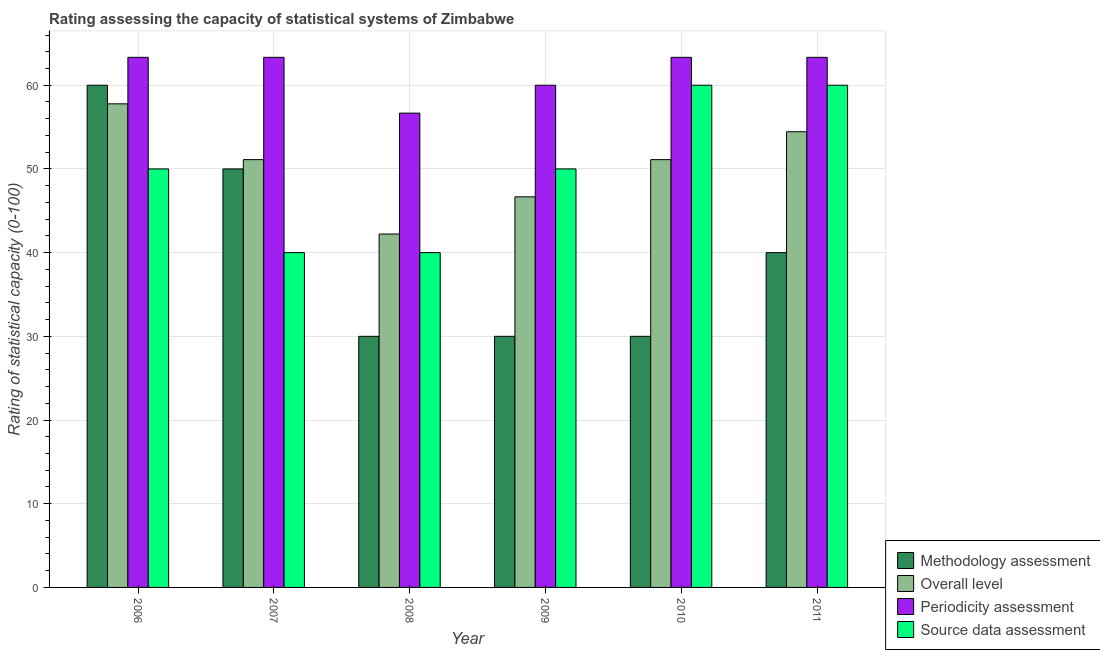How many groups of bars are there?
Make the answer very short. 6. Are the number of bars on each tick of the X-axis equal?
Provide a succinct answer. Yes. How many bars are there on the 3rd tick from the right?
Make the answer very short. 4. What is the periodicity assessment rating in 2006?
Make the answer very short. 63.33. Across all years, what is the maximum overall level rating?
Offer a very short reply. 57.78. Across all years, what is the minimum periodicity assessment rating?
Provide a short and direct response. 56.67. What is the total source data assessment rating in the graph?
Keep it short and to the point. 300. What is the difference between the overall level rating in 2007 and that in 2008?
Provide a short and direct response. 8.89. What is the difference between the source data assessment rating in 2008 and the periodicity assessment rating in 2010?
Give a very brief answer. -20. What is the average periodicity assessment rating per year?
Keep it short and to the point. 61.67. In the year 2008, what is the difference between the methodology assessment rating and source data assessment rating?
Your answer should be compact. 0. What is the ratio of the periodicity assessment rating in 2008 to that in 2011?
Offer a terse response. 0.89. Is the methodology assessment rating in 2006 less than that in 2010?
Provide a succinct answer. No. What is the difference between the highest and the lowest source data assessment rating?
Your answer should be very brief. 20. In how many years, is the overall level rating greater than the average overall level rating taken over all years?
Offer a terse response. 4. What does the 2nd bar from the left in 2010 represents?
Provide a short and direct response. Overall level. What does the 2nd bar from the right in 2010 represents?
Provide a short and direct response. Periodicity assessment. Is it the case that in every year, the sum of the methodology assessment rating and overall level rating is greater than the periodicity assessment rating?
Your answer should be compact. Yes. How many bars are there?
Offer a very short reply. 24. What is the difference between two consecutive major ticks on the Y-axis?
Provide a short and direct response. 10. Where does the legend appear in the graph?
Your answer should be very brief. Bottom right. How are the legend labels stacked?
Provide a succinct answer. Vertical. What is the title of the graph?
Offer a very short reply. Rating assessing the capacity of statistical systems of Zimbabwe. Does "Offering training" appear as one of the legend labels in the graph?
Ensure brevity in your answer.  No. What is the label or title of the X-axis?
Give a very brief answer. Year. What is the label or title of the Y-axis?
Make the answer very short. Rating of statistical capacity (0-100). What is the Rating of statistical capacity (0-100) in Overall level in 2006?
Ensure brevity in your answer.  57.78. What is the Rating of statistical capacity (0-100) of Periodicity assessment in 2006?
Give a very brief answer. 63.33. What is the Rating of statistical capacity (0-100) in Source data assessment in 2006?
Make the answer very short. 50. What is the Rating of statistical capacity (0-100) of Methodology assessment in 2007?
Provide a short and direct response. 50. What is the Rating of statistical capacity (0-100) of Overall level in 2007?
Provide a short and direct response. 51.11. What is the Rating of statistical capacity (0-100) in Periodicity assessment in 2007?
Offer a terse response. 63.33. What is the Rating of statistical capacity (0-100) in Overall level in 2008?
Ensure brevity in your answer.  42.22. What is the Rating of statistical capacity (0-100) in Periodicity assessment in 2008?
Ensure brevity in your answer.  56.67. What is the Rating of statistical capacity (0-100) in Methodology assessment in 2009?
Provide a succinct answer. 30. What is the Rating of statistical capacity (0-100) of Overall level in 2009?
Keep it short and to the point. 46.67. What is the Rating of statistical capacity (0-100) of Periodicity assessment in 2009?
Provide a short and direct response. 60. What is the Rating of statistical capacity (0-100) of Source data assessment in 2009?
Offer a terse response. 50. What is the Rating of statistical capacity (0-100) of Methodology assessment in 2010?
Provide a succinct answer. 30. What is the Rating of statistical capacity (0-100) of Overall level in 2010?
Offer a very short reply. 51.11. What is the Rating of statistical capacity (0-100) of Periodicity assessment in 2010?
Keep it short and to the point. 63.33. What is the Rating of statistical capacity (0-100) of Methodology assessment in 2011?
Your answer should be compact. 40. What is the Rating of statistical capacity (0-100) in Overall level in 2011?
Provide a short and direct response. 54.44. What is the Rating of statistical capacity (0-100) of Periodicity assessment in 2011?
Keep it short and to the point. 63.33. What is the Rating of statistical capacity (0-100) in Source data assessment in 2011?
Offer a very short reply. 60. Across all years, what is the maximum Rating of statistical capacity (0-100) in Methodology assessment?
Your answer should be compact. 60. Across all years, what is the maximum Rating of statistical capacity (0-100) of Overall level?
Give a very brief answer. 57.78. Across all years, what is the maximum Rating of statistical capacity (0-100) of Periodicity assessment?
Your answer should be very brief. 63.33. Across all years, what is the maximum Rating of statistical capacity (0-100) in Source data assessment?
Keep it short and to the point. 60. Across all years, what is the minimum Rating of statistical capacity (0-100) in Overall level?
Ensure brevity in your answer.  42.22. Across all years, what is the minimum Rating of statistical capacity (0-100) of Periodicity assessment?
Offer a terse response. 56.67. Across all years, what is the minimum Rating of statistical capacity (0-100) of Source data assessment?
Provide a succinct answer. 40. What is the total Rating of statistical capacity (0-100) in Methodology assessment in the graph?
Ensure brevity in your answer.  240. What is the total Rating of statistical capacity (0-100) of Overall level in the graph?
Provide a succinct answer. 303.33. What is the total Rating of statistical capacity (0-100) in Periodicity assessment in the graph?
Your answer should be very brief. 370. What is the total Rating of statistical capacity (0-100) of Source data assessment in the graph?
Offer a very short reply. 300. What is the difference between the Rating of statistical capacity (0-100) in Overall level in 2006 and that in 2007?
Provide a short and direct response. 6.67. What is the difference between the Rating of statistical capacity (0-100) of Periodicity assessment in 2006 and that in 2007?
Ensure brevity in your answer.  0. What is the difference between the Rating of statistical capacity (0-100) of Source data assessment in 2006 and that in 2007?
Offer a very short reply. 10. What is the difference between the Rating of statistical capacity (0-100) in Methodology assessment in 2006 and that in 2008?
Keep it short and to the point. 30. What is the difference between the Rating of statistical capacity (0-100) of Overall level in 2006 and that in 2008?
Give a very brief answer. 15.56. What is the difference between the Rating of statistical capacity (0-100) in Periodicity assessment in 2006 and that in 2008?
Provide a short and direct response. 6.67. What is the difference between the Rating of statistical capacity (0-100) of Source data assessment in 2006 and that in 2008?
Provide a short and direct response. 10. What is the difference between the Rating of statistical capacity (0-100) of Overall level in 2006 and that in 2009?
Ensure brevity in your answer.  11.11. What is the difference between the Rating of statistical capacity (0-100) in Source data assessment in 2006 and that in 2009?
Your response must be concise. 0. What is the difference between the Rating of statistical capacity (0-100) of Methodology assessment in 2006 and that in 2010?
Your response must be concise. 30. What is the difference between the Rating of statistical capacity (0-100) of Overall level in 2006 and that in 2010?
Your answer should be compact. 6.67. What is the difference between the Rating of statistical capacity (0-100) of Periodicity assessment in 2006 and that in 2010?
Provide a short and direct response. 0. What is the difference between the Rating of statistical capacity (0-100) of Source data assessment in 2006 and that in 2010?
Your response must be concise. -10. What is the difference between the Rating of statistical capacity (0-100) of Methodology assessment in 2006 and that in 2011?
Your response must be concise. 20. What is the difference between the Rating of statistical capacity (0-100) in Overall level in 2006 and that in 2011?
Your answer should be very brief. 3.33. What is the difference between the Rating of statistical capacity (0-100) of Periodicity assessment in 2006 and that in 2011?
Your response must be concise. 0. What is the difference between the Rating of statistical capacity (0-100) in Source data assessment in 2006 and that in 2011?
Offer a very short reply. -10. What is the difference between the Rating of statistical capacity (0-100) of Methodology assessment in 2007 and that in 2008?
Provide a short and direct response. 20. What is the difference between the Rating of statistical capacity (0-100) of Overall level in 2007 and that in 2008?
Keep it short and to the point. 8.89. What is the difference between the Rating of statistical capacity (0-100) in Source data assessment in 2007 and that in 2008?
Provide a short and direct response. 0. What is the difference between the Rating of statistical capacity (0-100) of Overall level in 2007 and that in 2009?
Ensure brevity in your answer.  4.44. What is the difference between the Rating of statistical capacity (0-100) in Periodicity assessment in 2007 and that in 2009?
Your answer should be very brief. 3.33. What is the difference between the Rating of statistical capacity (0-100) of Source data assessment in 2007 and that in 2009?
Your response must be concise. -10. What is the difference between the Rating of statistical capacity (0-100) of Methodology assessment in 2007 and that in 2010?
Offer a terse response. 20. What is the difference between the Rating of statistical capacity (0-100) in Periodicity assessment in 2007 and that in 2010?
Make the answer very short. 0. What is the difference between the Rating of statistical capacity (0-100) in Source data assessment in 2007 and that in 2010?
Make the answer very short. -20. What is the difference between the Rating of statistical capacity (0-100) of Methodology assessment in 2007 and that in 2011?
Your answer should be compact. 10. What is the difference between the Rating of statistical capacity (0-100) in Overall level in 2008 and that in 2009?
Offer a very short reply. -4.44. What is the difference between the Rating of statistical capacity (0-100) in Periodicity assessment in 2008 and that in 2009?
Give a very brief answer. -3.33. What is the difference between the Rating of statistical capacity (0-100) of Source data assessment in 2008 and that in 2009?
Give a very brief answer. -10. What is the difference between the Rating of statistical capacity (0-100) in Overall level in 2008 and that in 2010?
Provide a succinct answer. -8.89. What is the difference between the Rating of statistical capacity (0-100) in Periodicity assessment in 2008 and that in 2010?
Give a very brief answer. -6.67. What is the difference between the Rating of statistical capacity (0-100) in Overall level in 2008 and that in 2011?
Your response must be concise. -12.22. What is the difference between the Rating of statistical capacity (0-100) in Periodicity assessment in 2008 and that in 2011?
Your response must be concise. -6.67. What is the difference between the Rating of statistical capacity (0-100) in Methodology assessment in 2009 and that in 2010?
Make the answer very short. 0. What is the difference between the Rating of statistical capacity (0-100) of Overall level in 2009 and that in 2010?
Provide a succinct answer. -4.44. What is the difference between the Rating of statistical capacity (0-100) of Periodicity assessment in 2009 and that in 2010?
Give a very brief answer. -3.33. What is the difference between the Rating of statistical capacity (0-100) in Methodology assessment in 2009 and that in 2011?
Keep it short and to the point. -10. What is the difference between the Rating of statistical capacity (0-100) of Overall level in 2009 and that in 2011?
Your answer should be very brief. -7.78. What is the difference between the Rating of statistical capacity (0-100) in Periodicity assessment in 2009 and that in 2011?
Provide a succinct answer. -3.33. What is the difference between the Rating of statistical capacity (0-100) of Methodology assessment in 2010 and that in 2011?
Provide a succinct answer. -10. What is the difference between the Rating of statistical capacity (0-100) of Overall level in 2010 and that in 2011?
Your response must be concise. -3.33. What is the difference between the Rating of statistical capacity (0-100) in Periodicity assessment in 2010 and that in 2011?
Ensure brevity in your answer.  0. What is the difference between the Rating of statistical capacity (0-100) of Methodology assessment in 2006 and the Rating of statistical capacity (0-100) of Overall level in 2007?
Keep it short and to the point. 8.89. What is the difference between the Rating of statistical capacity (0-100) in Methodology assessment in 2006 and the Rating of statistical capacity (0-100) in Periodicity assessment in 2007?
Your answer should be compact. -3.33. What is the difference between the Rating of statistical capacity (0-100) in Methodology assessment in 2006 and the Rating of statistical capacity (0-100) in Source data assessment in 2007?
Give a very brief answer. 20. What is the difference between the Rating of statistical capacity (0-100) of Overall level in 2006 and the Rating of statistical capacity (0-100) of Periodicity assessment in 2007?
Give a very brief answer. -5.56. What is the difference between the Rating of statistical capacity (0-100) in Overall level in 2006 and the Rating of statistical capacity (0-100) in Source data assessment in 2007?
Offer a very short reply. 17.78. What is the difference between the Rating of statistical capacity (0-100) in Periodicity assessment in 2006 and the Rating of statistical capacity (0-100) in Source data assessment in 2007?
Make the answer very short. 23.33. What is the difference between the Rating of statistical capacity (0-100) of Methodology assessment in 2006 and the Rating of statistical capacity (0-100) of Overall level in 2008?
Your response must be concise. 17.78. What is the difference between the Rating of statistical capacity (0-100) of Methodology assessment in 2006 and the Rating of statistical capacity (0-100) of Periodicity assessment in 2008?
Your answer should be very brief. 3.33. What is the difference between the Rating of statistical capacity (0-100) of Overall level in 2006 and the Rating of statistical capacity (0-100) of Source data assessment in 2008?
Keep it short and to the point. 17.78. What is the difference between the Rating of statistical capacity (0-100) of Periodicity assessment in 2006 and the Rating of statistical capacity (0-100) of Source data assessment in 2008?
Give a very brief answer. 23.33. What is the difference between the Rating of statistical capacity (0-100) of Methodology assessment in 2006 and the Rating of statistical capacity (0-100) of Overall level in 2009?
Give a very brief answer. 13.33. What is the difference between the Rating of statistical capacity (0-100) in Methodology assessment in 2006 and the Rating of statistical capacity (0-100) in Periodicity assessment in 2009?
Offer a terse response. 0. What is the difference between the Rating of statistical capacity (0-100) of Overall level in 2006 and the Rating of statistical capacity (0-100) of Periodicity assessment in 2009?
Your answer should be compact. -2.22. What is the difference between the Rating of statistical capacity (0-100) in Overall level in 2006 and the Rating of statistical capacity (0-100) in Source data assessment in 2009?
Make the answer very short. 7.78. What is the difference between the Rating of statistical capacity (0-100) of Periodicity assessment in 2006 and the Rating of statistical capacity (0-100) of Source data assessment in 2009?
Give a very brief answer. 13.33. What is the difference between the Rating of statistical capacity (0-100) of Methodology assessment in 2006 and the Rating of statistical capacity (0-100) of Overall level in 2010?
Keep it short and to the point. 8.89. What is the difference between the Rating of statistical capacity (0-100) in Methodology assessment in 2006 and the Rating of statistical capacity (0-100) in Periodicity assessment in 2010?
Offer a very short reply. -3.33. What is the difference between the Rating of statistical capacity (0-100) in Overall level in 2006 and the Rating of statistical capacity (0-100) in Periodicity assessment in 2010?
Offer a terse response. -5.56. What is the difference between the Rating of statistical capacity (0-100) of Overall level in 2006 and the Rating of statistical capacity (0-100) of Source data assessment in 2010?
Your answer should be very brief. -2.22. What is the difference between the Rating of statistical capacity (0-100) in Periodicity assessment in 2006 and the Rating of statistical capacity (0-100) in Source data assessment in 2010?
Give a very brief answer. 3.33. What is the difference between the Rating of statistical capacity (0-100) in Methodology assessment in 2006 and the Rating of statistical capacity (0-100) in Overall level in 2011?
Your response must be concise. 5.56. What is the difference between the Rating of statistical capacity (0-100) in Methodology assessment in 2006 and the Rating of statistical capacity (0-100) in Periodicity assessment in 2011?
Keep it short and to the point. -3.33. What is the difference between the Rating of statistical capacity (0-100) of Methodology assessment in 2006 and the Rating of statistical capacity (0-100) of Source data assessment in 2011?
Give a very brief answer. 0. What is the difference between the Rating of statistical capacity (0-100) of Overall level in 2006 and the Rating of statistical capacity (0-100) of Periodicity assessment in 2011?
Give a very brief answer. -5.56. What is the difference between the Rating of statistical capacity (0-100) of Overall level in 2006 and the Rating of statistical capacity (0-100) of Source data assessment in 2011?
Ensure brevity in your answer.  -2.22. What is the difference between the Rating of statistical capacity (0-100) in Methodology assessment in 2007 and the Rating of statistical capacity (0-100) in Overall level in 2008?
Make the answer very short. 7.78. What is the difference between the Rating of statistical capacity (0-100) of Methodology assessment in 2007 and the Rating of statistical capacity (0-100) of Periodicity assessment in 2008?
Offer a terse response. -6.67. What is the difference between the Rating of statistical capacity (0-100) in Overall level in 2007 and the Rating of statistical capacity (0-100) in Periodicity assessment in 2008?
Keep it short and to the point. -5.56. What is the difference between the Rating of statistical capacity (0-100) of Overall level in 2007 and the Rating of statistical capacity (0-100) of Source data assessment in 2008?
Ensure brevity in your answer.  11.11. What is the difference between the Rating of statistical capacity (0-100) in Periodicity assessment in 2007 and the Rating of statistical capacity (0-100) in Source data assessment in 2008?
Your answer should be very brief. 23.33. What is the difference between the Rating of statistical capacity (0-100) in Methodology assessment in 2007 and the Rating of statistical capacity (0-100) in Overall level in 2009?
Provide a succinct answer. 3.33. What is the difference between the Rating of statistical capacity (0-100) in Methodology assessment in 2007 and the Rating of statistical capacity (0-100) in Source data assessment in 2009?
Ensure brevity in your answer.  0. What is the difference between the Rating of statistical capacity (0-100) in Overall level in 2007 and the Rating of statistical capacity (0-100) in Periodicity assessment in 2009?
Ensure brevity in your answer.  -8.89. What is the difference between the Rating of statistical capacity (0-100) in Periodicity assessment in 2007 and the Rating of statistical capacity (0-100) in Source data assessment in 2009?
Keep it short and to the point. 13.33. What is the difference between the Rating of statistical capacity (0-100) in Methodology assessment in 2007 and the Rating of statistical capacity (0-100) in Overall level in 2010?
Ensure brevity in your answer.  -1.11. What is the difference between the Rating of statistical capacity (0-100) in Methodology assessment in 2007 and the Rating of statistical capacity (0-100) in Periodicity assessment in 2010?
Your answer should be very brief. -13.33. What is the difference between the Rating of statistical capacity (0-100) of Methodology assessment in 2007 and the Rating of statistical capacity (0-100) of Source data assessment in 2010?
Your response must be concise. -10. What is the difference between the Rating of statistical capacity (0-100) of Overall level in 2007 and the Rating of statistical capacity (0-100) of Periodicity assessment in 2010?
Keep it short and to the point. -12.22. What is the difference between the Rating of statistical capacity (0-100) in Overall level in 2007 and the Rating of statistical capacity (0-100) in Source data assessment in 2010?
Provide a succinct answer. -8.89. What is the difference between the Rating of statistical capacity (0-100) in Periodicity assessment in 2007 and the Rating of statistical capacity (0-100) in Source data assessment in 2010?
Make the answer very short. 3.33. What is the difference between the Rating of statistical capacity (0-100) of Methodology assessment in 2007 and the Rating of statistical capacity (0-100) of Overall level in 2011?
Offer a very short reply. -4.44. What is the difference between the Rating of statistical capacity (0-100) in Methodology assessment in 2007 and the Rating of statistical capacity (0-100) in Periodicity assessment in 2011?
Your answer should be compact. -13.33. What is the difference between the Rating of statistical capacity (0-100) in Overall level in 2007 and the Rating of statistical capacity (0-100) in Periodicity assessment in 2011?
Provide a short and direct response. -12.22. What is the difference between the Rating of statistical capacity (0-100) in Overall level in 2007 and the Rating of statistical capacity (0-100) in Source data assessment in 2011?
Offer a terse response. -8.89. What is the difference between the Rating of statistical capacity (0-100) of Periodicity assessment in 2007 and the Rating of statistical capacity (0-100) of Source data assessment in 2011?
Offer a very short reply. 3.33. What is the difference between the Rating of statistical capacity (0-100) of Methodology assessment in 2008 and the Rating of statistical capacity (0-100) of Overall level in 2009?
Provide a short and direct response. -16.67. What is the difference between the Rating of statistical capacity (0-100) in Methodology assessment in 2008 and the Rating of statistical capacity (0-100) in Periodicity assessment in 2009?
Provide a succinct answer. -30. What is the difference between the Rating of statistical capacity (0-100) of Methodology assessment in 2008 and the Rating of statistical capacity (0-100) of Source data assessment in 2009?
Give a very brief answer. -20. What is the difference between the Rating of statistical capacity (0-100) of Overall level in 2008 and the Rating of statistical capacity (0-100) of Periodicity assessment in 2009?
Make the answer very short. -17.78. What is the difference between the Rating of statistical capacity (0-100) in Overall level in 2008 and the Rating of statistical capacity (0-100) in Source data assessment in 2009?
Your answer should be compact. -7.78. What is the difference between the Rating of statistical capacity (0-100) in Methodology assessment in 2008 and the Rating of statistical capacity (0-100) in Overall level in 2010?
Provide a succinct answer. -21.11. What is the difference between the Rating of statistical capacity (0-100) of Methodology assessment in 2008 and the Rating of statistical capacity (0-100) of Periodicity assessment in 2010?
Keep it short and to the point. -33.33. What is the difference between the Rating of statistical capacity (0-100) in Overall level in 2008 and the Rating of statistical capacity (0-100) in Periodicity assessment in 2010?
Your answer should be very brief. -21.11. What is the difference between the Rating of statistical capacity (0-100) in Overall level in 2008 and the Rating of statistical capacity (0-100) in Source data assessment in 2010?
Give a very brief answer. -17.78. What is the difference between the Rating of statistical capacity (0-100) of Methodology assessment in 2008 and the Rating of statistical capacity (0-100) of Overall level in 2011?
Offer a very short reply. -24.44. What is the difference between the Rating of statistical capacity (0-100) in Methodology assessment in 2008 and the Rating of statistical capacity (0-100) in Periodicity assessment in 2011?
Give a very brief answer. -33.33. What is the difference between the Rating of statistical capacity (0-100) in Methodology assessment in 2008 and the Rating of statistical capacity (0-100) in Source data assessment in 2011?
Your answer should be compact. -30. What is the difference between the Rating of statistical capacity (0-100) of Overall level in 2008 and the Rating of statistical capacity (0-100) of Periodicity assessment in 2011?
Make the answer very short. -21.11. What is the difference between the Rating of statistical capacity (0-100) in Overall level in 2008 and the Rating of statistical capacity (0-100) in Source data assessment in 2011?
Your answer should be very brief. -17.78. What is the difference between the Rating of statistical capacity (0-100) in Methodology assessment in 2009 and the Rating of statistical capacity (0-100) in Overall level in 2010?
Provide a short and direct response. -21.11. What is the difference between the Rating of statistical capacity (0-100) of Methodology assessment in 2009 and the Rating of statistical capacity (0-100) of Periodicity assessment in 2010?
Keep it short and to the point. -33.33. What is the difference between the Rating of statistical capacity (0-100) of Overall level in 2009 and the Rating of statistical capacity (0-100) of Periodicity assessment in 2010?
Offer a very short reply. -16.67. What is the difference between the Rating of statistical capacity (0-100) of Overall level in 2009 and the Rating of statistical capacity (0-100) of Source data assessment in 2010?
Keep it short and to the point. -13.33. What is the difference between the Rating of statistical capacity (0-100) of Periodicity assessment in 2009 and the Rating of statistical capacity (0-100) of Source data assessment in 2010?
Keep it short and to the point. 0. What is the difference between the Rating of statistical capacity (0-100) in Methodology assessment in 2009 and the Rating of statistical capacity (0-100) in Overall level in 2011?
Give a very brief answer. -24.44. What is the difference between the Rating of statistical capacity (0-100) in Methodology assessment in 2009 and the Rating of statistical capacity (0-100) in Periodicity assessment in 2011?
Keep it short and to the point. -33.33. What is the difference between the Rating of statistical capacity (0-100) of Overall level in 2009 and the Rating of statistical capacity (0-100) of Periodicity assessment in 2011?
Your response must be concise. -16.67. What is the difference between the Rating of statistical capacity (0-100) in Overall level in 2009 and the Rating of statistical capacity (0-100) in Source data assessment in 2011?
Offer a very short reply. -13.33. What is the difference between the Rating of statistical capacity (0-100) in Periodicity assessment in 2009 and the Rating of statistical capacity (0-100) in Source data assessment in 2011?
Ensure brevity in your answer.  0. What is the difference between the Rating of statistical capacity (0-100) of Methodology assessment in 2010 and the Rating of statistical capacity (0-100) of Overall level in 2011?
Your answer should be compact. -24.44. What is the difference between the Rating of statistical capacity (0-100) of Methodology assessment in 2010 and the Rating of statistical capacity (0-100) of Periodicity assessment in 2011?
Keep it short and to the point. -33.33. What is the difference between the Rating of statistical capacity (0-100) in Methodology assessment in 2010 and the Rating of statistical capacity (0-100) in Source data assessment in 2011?
Ensure brevity in your answer.  -30. What is the difference between the Rating of statistical capacity (0-100) in Overall level in 2010 and the Rating of statistical capacity (0-100) in Periodicity assessment in 2011?
Provide a short and direct response. -12.22. What is the difference between the Rating of statistical capacity (0-100) of Overall level in 2010 and the Rating of statistical capacity (0-100) of Source data assessment in 2011?
Make the answer very short. -8.89. What is the difference between the Rating of statistical capacity (0-100) in Periodicity assessment in 2010 and the Rating of statistical capacity (0-100) in Source data assessment in 2011?
Offer a terse response. 3.33. What is the average Rating of statistical capacity (0-100) in Methodology assessment per year?
Your response must be concise. 40. What is the average Rating of statistical capacity (0-100) of Overall level per year?
Give a very brief answer. 50.56. What is the average Rating of statistical capacity (0-100) in Periodicity assessment per year?
Provide a succinct answer. 61.67. What is the average Rating of statistical capacity (0-100) of Source data assessment per year?
Ensure brevity in your answer.  50. In the year 2006, what is the difference between the Rating of statistical capacity (0-100) of Methodology assessment and Rating of statistical capacity (0-100) of Overall level?
Provide a short and direct response. 2.22. In the year 2006, what is the difference between the Rating of statistical capacity (0-100) of Methodology assessment and Rating of statistical capacity (0-100) of Periodicity assessment?
Keep it short and to the point. -3.33. In the year 2006, what is the difference between the Rating of statistical capacity (0-100) in Methodology assessment and Rating of statistical capacity (0-100) in Source data assessment?
Your response must be concise. 10. In the year 2006, what is the difference between the Rating of statistical capacity (0-100) in Overall level and Rating of statistical capacity (0-100) in Periodicity assessment?
Your answer should be compact. -5.56. In the year 2006, what is the difference between the Rating of statistical capacity (0-100) of Overall level and Rating of statistical capacity (0-100) of Source data assessment?
Keep it short and to the point. 7.78. In the year 2006, what is the difference between the Rating of statistical capacity (0-100) of Periodicity assessment and Rating of statistical capacity (0-100) of Source data assessment?
Offer a terse response. 13.33. In the year 2007, what is the difference between the Rating of statistical capacity (0-100) in Methodology assessment and Rating of statistical capacity (0-100) in Overall level?
Keep it short and to the point. -1.11. In the year 2007, what is the difference between the Rating of statistical capacity (0-100) of Methodology assessment and Rating of statistical capacity (0-100) of Periodicity assessment?
Your response must be concise. -13.33. In the year 2007, what is the difference between the Rating of statistical capacity (0-100) in Methodology assessment and Rating of statistical capacity (0-100) in Source data assessment?
Give a very brief answer. 10. In the year 2007, what is the difference between the Rating of statistical capacity (0-100) of Overall level and Rating of statistical capacity (0-100) of Periodicity assessment?
Your answer should be compact. -12.22. In the year 2007, what is the difference between the Rating of statistical capacity (0-100) in Overall level and Rating of statistical capacity (0-100) in Source data assessment?
Give a very brief answer. 11.11. In the year 2007, what is the difference between the Rating of statistical capacity (0-100) of Periodicity assessment and Rating of statistical capacity (0-100) of Source data assessment?
Your answer should be very brief. 23.33. In the year 2008, what is the difference between the Rating of statistical capacity (0-100) in Methodology assessment and Rating of statistical capacity (0-100) in Overall level?
Your answer should be compact. -12.22. In the year 2008, what is the difference between the Rating of statistical capacity (0-100) of Methodology assessment and Rating of statistical capacity (0-100) of Periodicity assessment?
Offer a very short reply. -26.67. In the year 2008, what is the difference between the Rating of statistical capacity (0-100) in Methodology assessment and Rating of statistical capacity (0-100) in Source data assessment?
Your response must be concise. -10. In the year 2008, what is the difference between the Rating of statistical capacity (0-100) of Overall level and Rating of statistical capacity (0-100) of Periodicity assessment?
Your answer should be very brief. -14.44. In the year 2008, what is the difference between the Rating of statistical capacity (0-100) in Overall level and Rating of statistical capacity (0-100) in Source data assessment?
Provide a succinct answer. 2.22. In the year 2008, what is the difference between the Rating of statistical capacity (0-100) of Periodicity assessment and Rating of statistical capacity (0-100) of Source data assessment?
Your response must be concise. 16.67. In the year 2009, what is the difference between the Rating of statistical capacity (0-100) in Methodology assessment and Rating of statistical capacity (0-100) in Overall level?
Your response must be concise. -16.67. In the year 2009, what is the difference between the Rating of statistical capacity (0-100) in Overall level and Rating of statistical capacity (0-100) in Periodicity assessment?
Provide a short and direct response. -13.33. In the year 2009, what is the difference between the Rating of statistical capacity (0-100) in Overall level and Rating of statistical capacity (0-100) in Source data assessment?
Offer a very short reply. -3.33. In the year 2009, what is the difference between the Rating of statistical capacity (0-100) in Periodicity assessment and Rating of statistical capacity (0-100) in Source data assessment?
Give a very brief answer. 10. In the year 2010, what is the difference between the Rating of statistical capacity (0-100) in Methodology assessment and Rating of statistical capacity (0-100) in Overall level?
Your answer should be very brief. -21.11. In the year 2010, what is the difference between the Rating of statistical capacity (0-100) of Methodology assessment and Rating of statistical capacity (0-100) of Periodicity assessment?
Provide a succinct answer. -33.33. In the year 2010, what is the difference between the Rating of statistical capacity (0-100) of Overall level and Rating of statistical capacity (0-100) of Periodicity assessment?
Keep it short and to the point. -12.22. In the year 2010, what is the difference between the Rating of statistical capacity (0-100) of Overall level and Rating of statistical capacity (0-100) of Source data assessment?
Your answer should be compact. -8.89. In the year 2011, what is the difference between the Rating of statistical capacity (0-100) of Methodology assessment and Rating of statistical capacity (0-100) of Overall level?
Keep it short and to the point. -14.44. In the year 2011, what is the difference between the Rating of statistical capacity (0-100) of Methodology assessment and Rating of statistical capacity (0-100) of Periodicity assessment?
Your answer should be very brief. -23.33. In the year 2011, what is the difference between the Rating of statistical capacity (0-100) of Methodology assessment and Rating of statistical capacity (0-100) of Source data assessment?
Offer a very short reply. -20. In the year 2011, what is the difference between the Rating of statistical capacity (0-100) of Overall level and Rating of statistical capacity (0-100) of Periodicity assessment?
Offer a terse response. -8.89. In the year 2011, what is the difference between the Rating of statistical capacity (0-100) of Overall level and Rating of statistical capacity (0-100) of Source data assessment?
Make the answer very short. -5.56. In the year 2011, what is the difference between the Rating of statistical capacity (0-100) in Periodicity assessment and Rating of statistical capacity (0-100) in Source data assessment?
Give a very brief answer. 3.33. What is the ratio of the Rating of statistical capacity (0-100) of Methodology assessment in 2006 to that in 2007?
Give a very brief answer. 1.2. What is the ratio of the Rating of statistical capacity (0-100) in Overall level in 2006 to that in 2007?
Offer a very short reply. 1.13. What is the ratio of the Rating of statistical capacity (0-100) in Overall level in 2006 to that in 2008?
Keep it short and to the point. 1.37. What is the ratio of the Rating of statistical capacity (0-100) of Periodicity assessment in 2006 to that in 2008?
Offer a terse response. 1.12. What is the ratio of the Rating of statistical capacity (0-100) in Overall level in 2006 to that in 2009?
Your answer should be compact. 1.24. What is the ratio of the Rating of statistical capacity (0-100) in Periodicity assessment in 2006 to that in 2009?
Your answer should be very brief. 1.06. What is the ratio of the Rating of statistical capacity (0-100) in Methodology assessment in 2006 to that in 2010?
Offer a very short reply. 2. What is the ratio of the Rating of statistical capacity (0-100) of Overall level in 2006 to that in 2010?
Your answer should be compact. 1.13. What is the ratio of the Rating of statistical capacity (0-100) in Source data assessment in 2006 to that in 2010?
Ensure brevity in your answer.  0.83. What is the ratio of the Rating of statistical capacity (0-100) of Overall level in 2006 to that in 2011?
Ensure brevity in your answer.  1.06. What is the ratio of the Rating of statistical capacity (0-100) of Periodicity assessment in 2006 to that in 2011?
Offer a terse response. 1. What is the ratio of the Rating of statistical capacity (0-100) of Source data assessment in 2006 to that in 2011?
Give a very brief answer. 0.83. What is the ratio of the Rating of statistical capacity (0-100) in Overall level in 2007 to that in 2008?
Ensure brevity in your answer.  1.21. What is the ratio of the Rating of statistical capacity (0-100) of Periodicity assessment in 2007 to that in 2008?
Offer a very short reply. 1.12. What is the ratio of the Rating of statistical capacity (0-100) in Source data assessment in 2007 to that in 2008?
Provide a short and direct response. 1. What is the ratio of the Rating of statistical capacity (0-100) of Overall level in 2007 to that in 2009?
Your answer should be very brief. 1.1. What is the ratio of the Rating of statistical capacity (0-100) in Periodicity assessment in 2007 to that in 2009?
Your answer should be compact. 1.06. What is the ratio of the Rating of statistical capacity (0-100) of Methodology assessment in 2007 to that in 2010?
Keep it short and to the point. 1.67. What is the ratio of the Rating of statistical capacity (0-100) of Methodology assessment in 2007 to that in 2011?
Provide a succinct answer. 1.25. What is the ratio of the Rating of statistical capacity (0-100) of Overall level in 2007 to that in 2011?
Offer a very short reply. 0.94. What is the ratio of the Rating of statistical capacity (0-100) of Periodicity assessment in 2007 to that in 2011?
Make the answer very short. 1. What is the ratio of the Rating of statistical capacity (0-100) of Source data assessment in 2007 to that in 2011?
Provide a short and direct response. 0.67. What is the ratio of the Rating of statistical capacity (0-100) in Methodology assessment in 2008 to that in 2009?
Make the answer very short. 1. What is the ratio of the Rating of statistical capacity (0-100) in Overall level in 2008 to that in 2009?
Your answer should be very brief. 0.9. What is the ratio of the Rating of statistical capacity (0-100) of Overall level in 2008 to that in 2010?
Give a very brief answer. 0.83. What is the ratio of the Rating of statistical capacity (0-100) of Periodicity assessment in 2008 to that in 2010?
Keep it short and to the point. 0.89. What is the ratio of the Rating of statistical capacity (0-100) in Overall level in 2008 to that in 2011?
Give a very brief answer. 0.78. What is the ratio of the Rating of statistical capacity (0-100) of Periodicity assessment in 2008 to that in 2011?
Your response must be concise. 0.89. What is the ratio of the Rating of statistical capacity (0-100) of Source data assessment in 2008 to that in 2011?
Your answer should be very brief. 0.67. What is the ratio of the Rating of statistical capacity (0-100) of Methodology assessment in 2009 to that in 2010?
Your answer should be compact. 1. What is the ratio of the Rating of statistical capacity (0-100) in Source data assessment in 2009 to that in 2010?
Provide a short and direct response. 0.83. What is the ratio of the Rating of statistical capacity (0-100) in Periodicity assessment in 2009 to that in 2011?
Make the answer very short. 0.95. What is the ratio of the Rating of statistical capacity (0-100) in Overall level in 2010 to that in 2011?
Your answer should be compact. 0.94. What is the ratio of the Rating of statistical capacity (0-100) in Source data assessment in 2010 to that in 2011?
Ensure brevity in your answer.  1. What is the difference between the highest and the second highest Rating of statistical capacity (0-100) of Methodology assessment?
Keep it short and to the point. 10. What is the difference between the highest and the second highest Rating of statistical capacity (0-100) of Periodicity assessment?
Offer a very short reply. 0. What is the difference between the highest and the lowest Rating of statistical capacity (0-100) of Methodology assessment?
Give a very brief answer. 30. What is the difference between the highest and the lowest Rating of statistical capacity (0-100) of Overall level?
Your response must be concise. 15.56. What is the difference between the highest and the lowest Rating of statistical capacity (0-100) of Periodicity assessment?
Offer a terse response. 6.67. What is the difference between the highest and the lowest Rating of statistical capacity (0-100) of Source data assessment?
Ensure brevity in your answer.  20. 